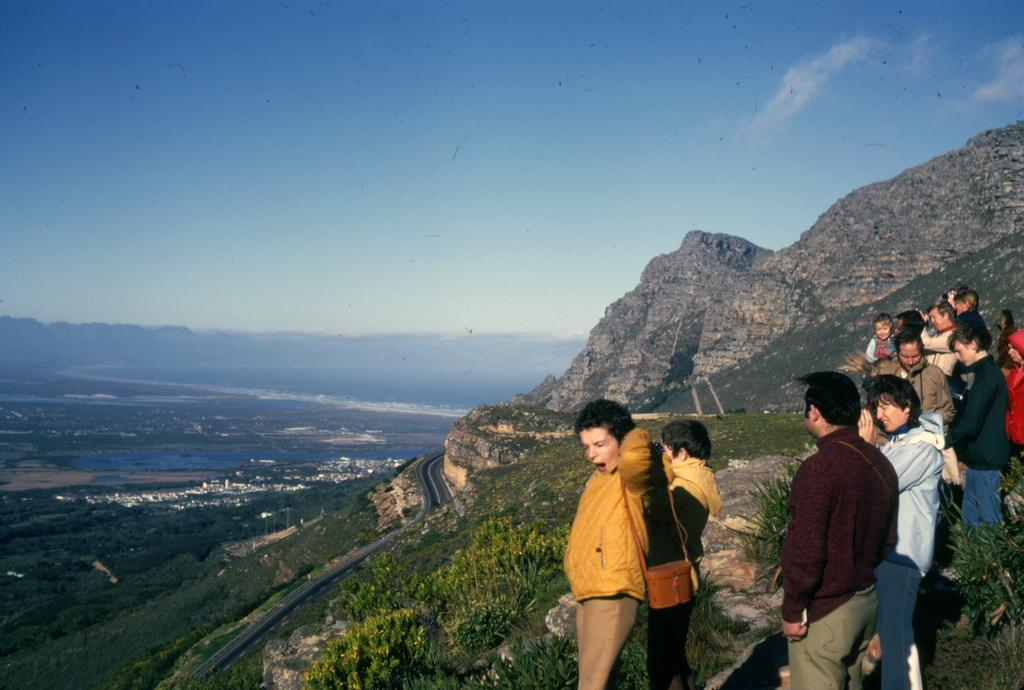What is the main subject of the image? The main subject of the image is a beautiful view of the hill. Are there any people in the image? Yes, there is a group of a man and woman standing on the hill. What can be seen in the background of the image? There are big mountains with trees in the background of the image. Can you see a swing in the image? No, there is no swing present in the image. How many snails are visible on the hill in the image? There are no snails visible on the hill in the image. 